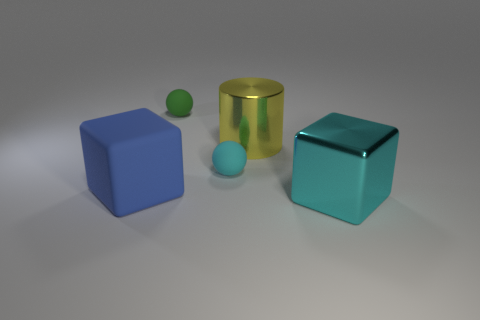Add 2 big yellow rubber cubes. How many objects exist? 7 Subtract all cylinders. How many objects are left? 4 Add 4 yellow shiny cylinders. How many yellow shiny cylinders exist? 5 Subtract 0 brown cylinders. How many objects are left? 5 Subtract all large yellow cylinders. Subtract all big green matte things. How many objects are left? 4 Add 5 big things. How many big things are left? 8 